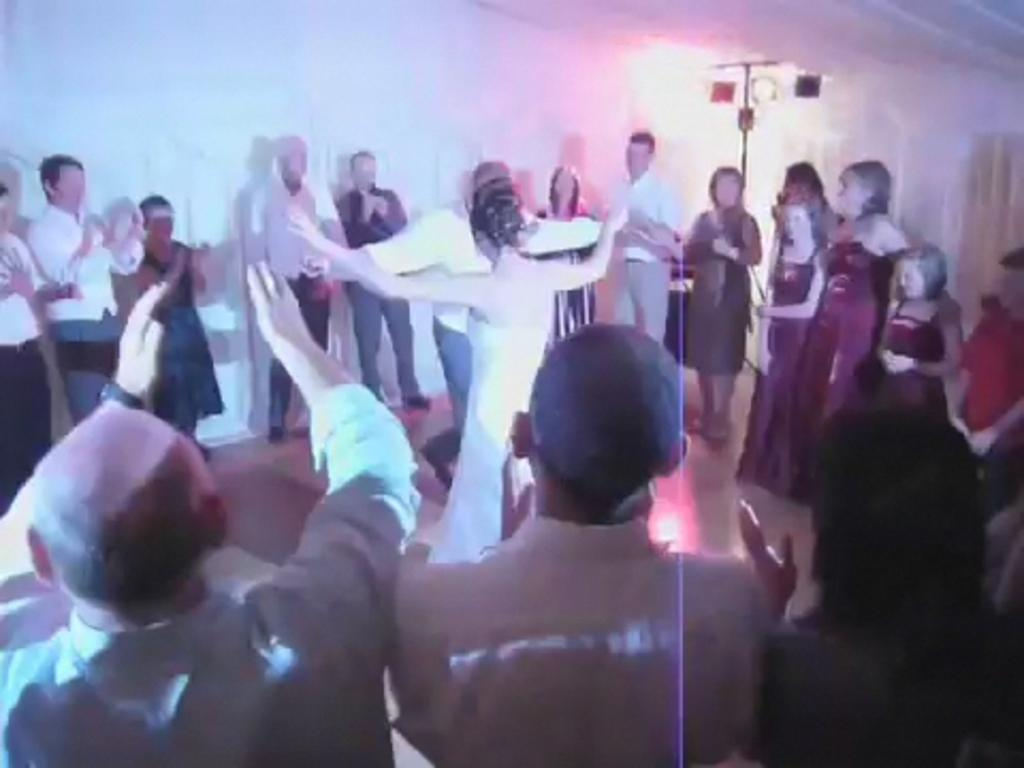What is the main setting of the image? There is a room in the image. What are the couple in the room doing? The couple is dancing in the room. Are there any other people in the room besides the dancing couple? Yes, people are present in the room. What are the other people in the room doing? The people are cheering. What type of drum can be seen on the calendar in the image? There is no drum or calendar present in the image. How many dimes are visible on the floor in the image? There are no dimes visible on the floor in the image. 